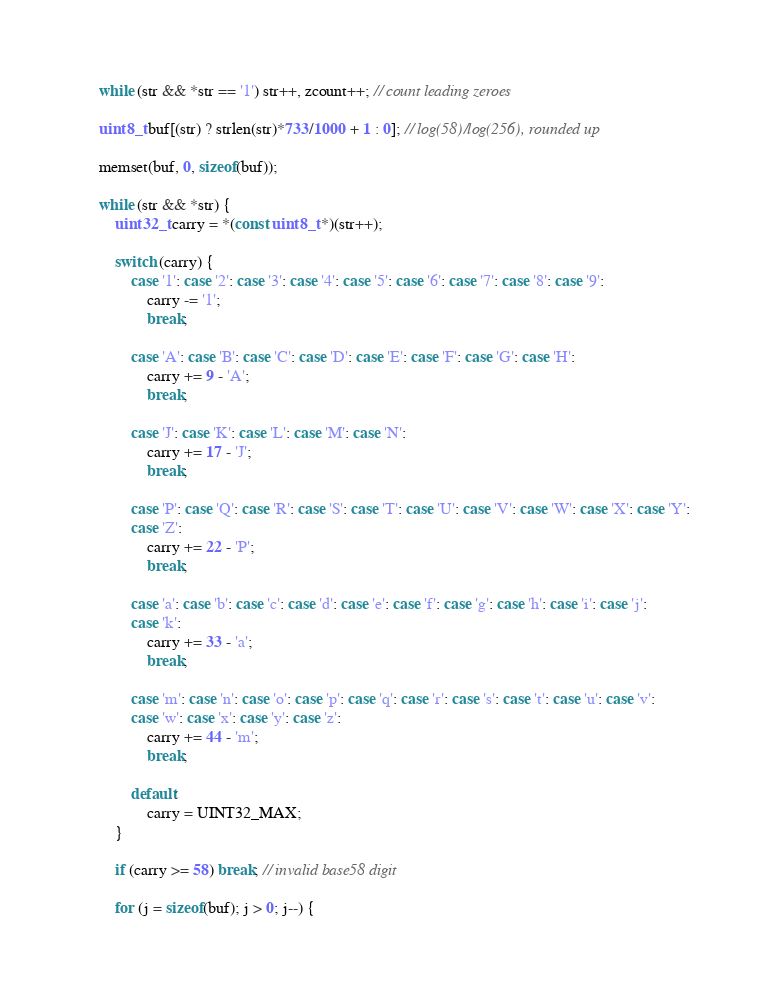Convert code to text. <code><loc_0><loc_0><loc_500><loc_500><_C_>    while (str && *str == '1') str++, zcount++; // count leading zeroes
    
    uint8_t buf[(str) ? strlen(str)*733/1000 + 1 : 0]; // log(58)/log(256), rounded up
    
    memset(buf, 0, sizeof(buf));
    
    while (str && *str) {
        uint32_t carry = *(const uint8_t *)(str++);
        
        switch (carry) {
            case '1': case '2': case '3': case '4': case '5': case '6': case '7': case '8': case '9':
                carry -= '1';
                break;
                
            case 'A': case 'B': case 'C': case 'D': case 'E': case 'F': case 'G': case 'H':
                carry += 9 - 'A';
                break;
                
            case 'J': case 'K': case 'L': case 'M': case 'N':
                carry += 17 - 'J';
                break;
                
            case 'P': case 'Q': case 'R': case 'S': case 'T': case 'U': case 'V': case 'W': case 'X': case 'Y':
            case 'Z':
                carry += 22 - 'P';
                break;
                
            case 'a': case 'b': case 'c': case 'd': case 'e': case 'f': case 'g': case 'h': case 'i': case 'j':
            case 'k':
                carry += 33 - 'a';
                break;
                
            case 'm': case 'n': case 'o': case 'p': case 'q': case 'r': case 's': case 't': case 'u': case 'v':
            case 'w': case 'x': case 'y': case 'z':
                carry += 44 - 'm';
                break;
                
            default:
                carry = UINT32_MAX;
        }
        
        if (carry >= 58) break; // invalid base58 digit
        
        for (j = sizeof(buf); j > 0; j--) {</code> 